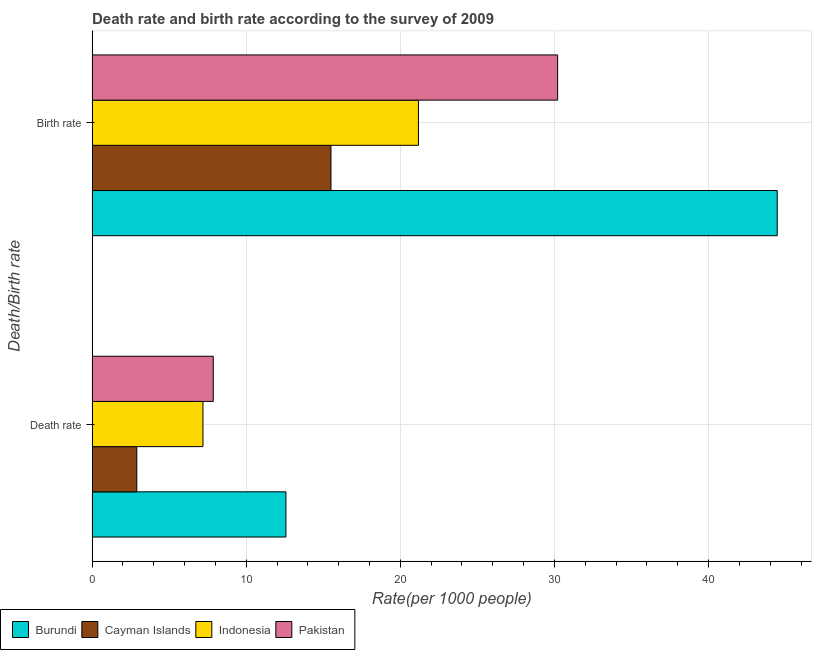How many groups of bars are there?
Give a very brief answer. 2. Are the number of bars on each tick of the Y-axis equal?
Give a very brief answer. Yes. What is the label of the 1st group of bars from the top?
Provide a succinct answer. Birth rate. Across all countries, what is the maximum death rate?
Provide a short and direct response. 12.58. In which country was the death rate maximum?
Your answer should be compact. Burundi. In which country was the birth rate minimum?
Keep it short and to the point. Cayman Islands. What is the total death rate in the graph?
Your answer should be very brief. 30.53. What is the difference between the death rate in Cayman Islands and that in Burundi?
Your answer should be very brief. -9.68. What is the difference between the death rate in Pakistan and the birth rate in Burundi?
Your answer should be compact. -36.6. What is the average birth rate per country?
Make the answer very short. 27.84. What is the difference between the birth rate and death rate in Burundi?
Provide a succinct answer. 31.88. What is the ratio of the death rate in Cayman Islands to that in Burundi?
Your response must be concise. 0.23. Is the death rate in Indonesia less than that in Burundi?
Your answer should be very brief. Yes. In how many countries, is the birth rate greater than the average birth rate taken over all countries?
Give a very brief answer. 2. What does the 2nd bar from the top in Death rate represents?
Ensure brevity in your answer.  Indonesia. What does the 2nd bar from the bottom in Birth rate represents?
Make the answer very short. Cayman Islands. How many bars are there?
Offer a terse response. 8. Are all the bars in the graph horizontal?
Give a very brief answer. Yes. How many countries are there in the graph?
Make the answer very short. 4. What is the difference between two consecutive major ticks on the X-axis?
Keep it short and to the point. 10. Are the values on the major ticks of X-axis written in scientific E-notation?
Give a very brief answer. No. How are the legend labels stacked?
Your response must be concise. Horizontal. What is the title of the graph?
Your answer should be very brief. Death rate and birth rate according to the survey of 2009. Does "Other small states" appear as one of the legend labels in the graph?
Your response must be concise. No. What is the label or title of the X-axis?
Give a very brief answer. Rate(per 1000 people). What is the label or title of the Y-axis?
Give a very brief answer. Death/Birth rate. What is the Rate(per 1000 people) of Burundi in Death rate?
Provide a short and direct response. 12.58. What is the Rate(per 1000 people) in Cayman Islands in Death rate?
Ensure brevity in your answer.  2.9. What is the Rate(per 1000 people) in Indonesia in Death rate?
Make the answer very short. 7.19. What is the Rate(per 1000 people) in Pakistan in Death rate?
Offer a terse response. 7.86. What is the Rate(per 1000 people) of Burundi in Birth rate?
Your answer should be compact. 44.46. What is the Rate(per 1000 people) in Cayman Islands in Birth rate?
Your response must be concise. 15.5. What is the Rate(per 1000 people) of Indonesia in Birth rate?
Ensure brevity in your answer.  21.18. What is the Rate(per 1000 people) of Pakistan in Birth rate?
Your answer should be compact. 30.21. Across all Death/Birth rate, what is the maximum Rate(per 1000 people) in Burundi?
Provide a succinct answer. 44.46. Across all Death/Birth rate, what is the maximum Rate(per 1000 people) in Indonesia?
Provide a short and direct response. 21.18. Across all Death/Birth rate, what is the maximum Rate(per 1000 people) in Pakistan?
Keep it short and to the point. 30.21. Across all Death/Birth rate, what is the minimum Rate(per 1000 people) in Burundi?
Provide a succinct answer. 12.58. Across all Death/Birth rate, what is the minimum Rate(per 1000 people) in Cayman Islands?
Your response must be concise. 2.9. Across all Death/Birth rate, what is the minimum Rate(per 1000 people) in Indonesia?
Offer a very short reply. 7.19. Across all Death/Birth rate, what is the minimum Rate(per 1000 people) of Pakistan?
Your answer should be compact. 7.86. What is the total Rate(per 1000 people) of Burundi in the graph?
Provide a short and direct response. 57.03. What is the total Rate(per 1000 people) of Indonesia in the graph?
Your answer should be very brief. 28.37. What is the total Rate(per 1000 people) of Pakistan in the graph?
Give a very brief answer. 38.07. What is the difference between the Rate(per 1000 people) of Burundi in Death rate and that in Birth rate?
Your answer should be compact. -31.88. What is the difference between the Rate(per 1000 people) of Cayman Islands in Death rate and that in Birth rate?
Keep it short and to the point. -12.6. What is the difference between the Rate(per 1000 people) of Indonesia in Death rate and that in Birth rate?
Your answer should be compact. -13.98. What is the difference between the Rate(per 1000 people) of Pakistan in Death rate and that in Birth rate?
Offer a terse response. -22.35. What is the difference between the Rate(per 1000 people) of Burundi in Death rate and the Rate(per 1000 people) of Cayman Islands in Birth rate?
Your answer should be compact. -2.92. What is the difference between the Rate(per 1000 people) of Burundi in Death rate and the Rate(per 1000 people) of Indonesia in Birth rate?
Your answer should be compact. -8.6. What is the difference between the Rate(per 1000 people) of Burundi in Death rate and the Rate(per 1000 people) of Pakistan in Birth rate?
Your answer should be very brief. -17.63. What is the difference between the Rate(per 1000 people) in Cayman Islands in Death rate and the Rate(per 1000 people) in Indonesia in Birth rate?
Your answer should be compact. -18.28. What is the difference between the Rate(per 1000 people) in Cayman Islands in Death rate and the Rate(per 1000 people) in Pakistan in Birth rate?
Provide a succinct answer. -27.31. What is the difference between the Rate(per 1000 people) in Indonesia in Death rate and the Rate(per 1000 people) in Pakistan in Birth rate?
Give a very brief answer. -23.01. What is the average Rate(per 1000 people) in Burundi per Death/Birth rate?
Provide a short and direct response. 28.52. What is the average Rate(per 1000 people) of Cayman Islands per Death/Birth rate?
Ensure brevity in your answer.  9.2. What is the average Rate(per 1000 people) in Indonesia per Death/Birth rate?
Your answer should be compact. 14.19. What is the average Rate(per 1000 people) in Pakistan per Death/Birth rate?
Give a very brief answer. 19.04. What is the difference between the Rate(per 1000 people) in Burundi and Rate(per 1000 people) in Cayman Islands in Death rate?
Offer a very short reply. 9.68. What is the difference between the Rate(per 1000 people) of Burundi and Rate(per 1000 people) of Indonesia in Death rate?
Give a very brief answer. 5.38. What is the difference between the Rate(per 1000 people) of Burundi and Rate(per 1000 people) of Pakistan in Death rate?
Offer a very short reply. 4.71. What is the difference between the Rate(per 1000 people) of Cayman Islands and Rate(per 1000 people) of Indonesia in Death rate?
Offer a very short reply. -4.29. What is the difference between the Rate(per 1000 people) in Cayman Islands and Rate(per 1000 people) in Pakistan in Death rate?
Make the answer very short. -4.96. What is the difference between the Rate(per 1000 people) in Indonesia and Rate(per 1000 people) in Pakistan in Death rate?
Provide a short and direct response. -0.67. What is the difference between the Rate(per 1000 people) in Burundi and Rate(per 1000 people) in Cayman Islands in Birth rate?
Provide a succinct answer. 28.96. What is the difference between the Rate(per 1000 people) of Burundi and Rate(per 1000 people) of Indonesia in Birth rate?
Your answer should be very brief. 23.28. What is the difference between the Rate(per 1000 people) in Burundi and Rate(per 1000 people) in Pakistan in Birth rate?
Give a very brief answer. 14.25. What is the difference between the Rate(per 1000 people) of Cayman Islands and Rate(per 1000 people) of Indonesia in Birth rate?
Your answer should be compact. -5.68. What is the difference between the Rate(per 1000 people) in Cayman Islands and Rate(per 1000 people) in Pakistan in Birth rate?
Give a very brief answer. -14.71. What is the difference between the Rate(per 1000 people) in Indonesia and Rate(per 1000 people) in Pakistan in Birth rate?
Keep it short and to the point. -9.03. What is the ratio of the Rate(per 1000 people) in Burundi in Death rate to that in Birth rate?
Ensure brevity in your answer.  0.28. What is the ratio of the Rate(per 1000 people) of Cayman Islands in Death rate to that in Birth rate?
Keep it short and to the point. 0.19. What is the ratio of the Rate(per 1000 people) of Indonesia in Death rate to that in Birth rate?
Your response must be concise. 0.34. What is the ratio of the Rate(per 1000 people) of Pakistan in Death rate to that in Birth rate?
Offer a very short reply. 0.26. What is the difference between the highest and the second highest Rate(per 1000 people) in Burundi?
Your answer should be compact. 31.88. What is the difference between the highest and the second highest Rate(per 1000 people) in Indonesia?
Provide a short and direct response. 13.98. What is the difference between the highest and the second highest Rate(per 1000 people) of Pakistan?
Provide a short and direct response. 22.35. What is the difference between the highest and the lowest Rate(per 1000 people) in Burundi?
Provide a short and direct response. 31.88. What is the difference between the highest and the lowest Rate(per 1000 people) of Cayman Islands?
Ensure brevity in your answer.  12.6. What is the difference between the highest and the lowest Rate(per 1000 people) of Indonesia?
Keep it short and to the point. 13.98. What is the difference between the highest and the lowest Rate(per 1000 people) in Pakistan?
Offer a terse response. 22.35. 